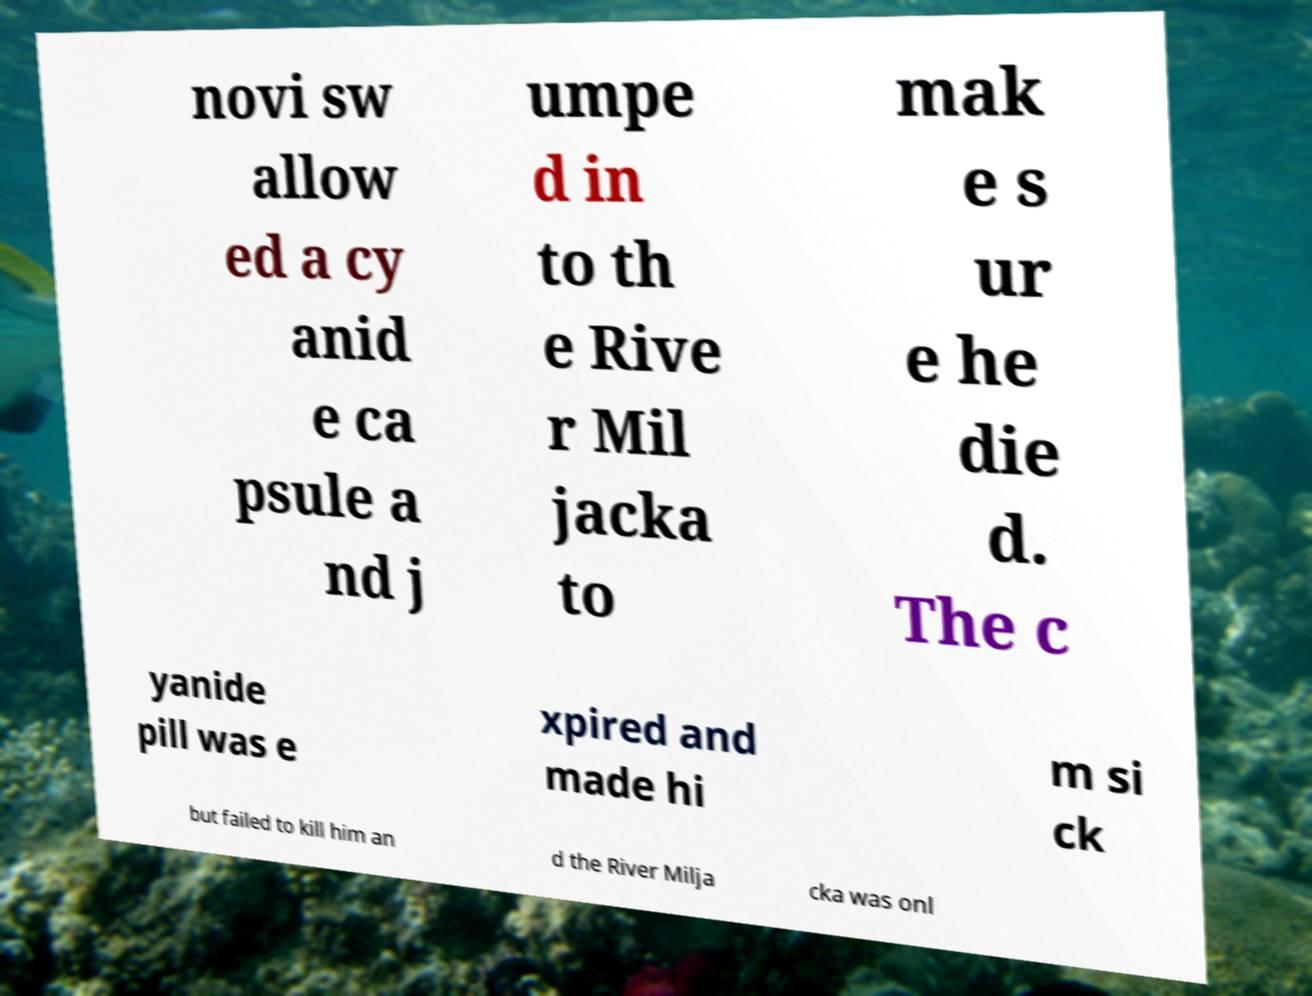For documentation purposes, I need the text within this image transcribed. Could you provide that? novi sw allow ed a cy anid e ca psule a nd j umpe d in to th e Rive r Mil jacka to mak e s ur e he die d. The c yanide pill was e xpired and made hi m si ck but failed to kill him an d the River Milja cka was onl 